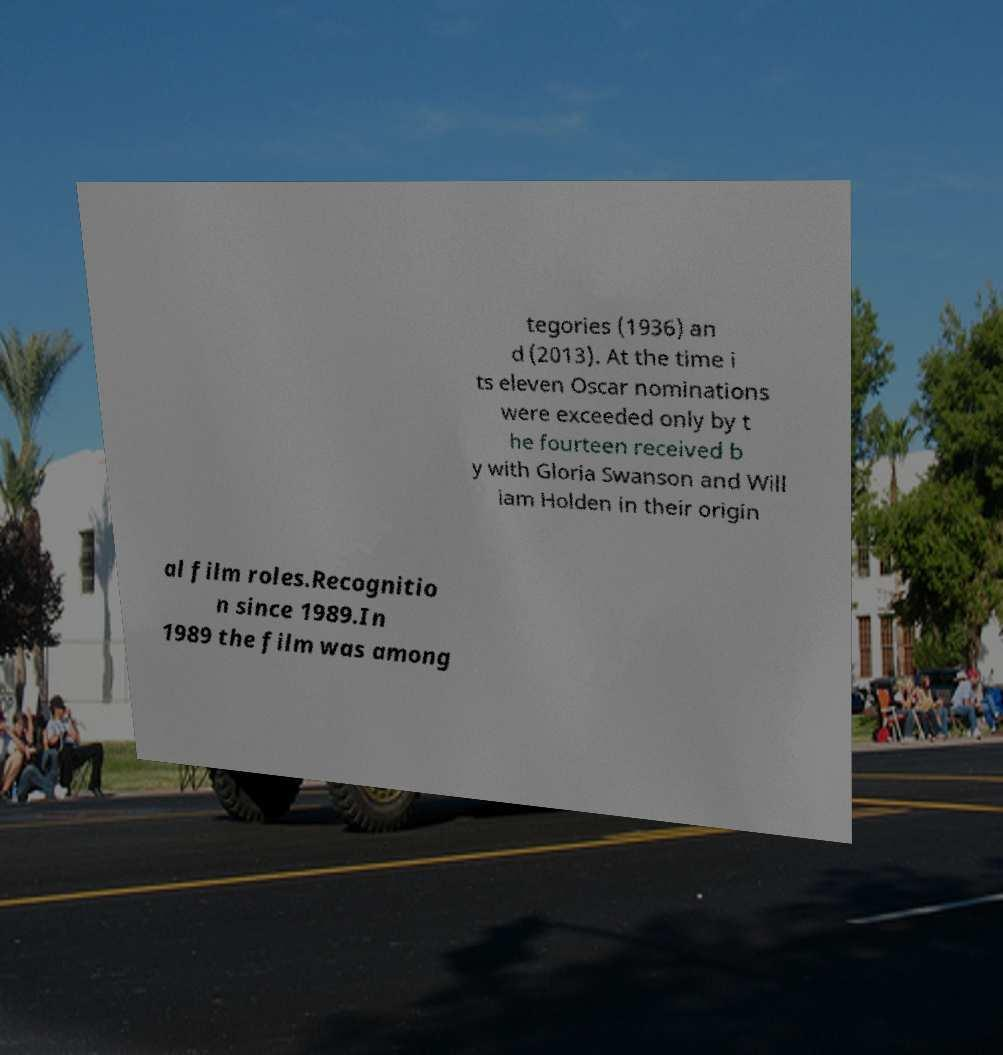Please identify and transcribe the text found in this image. tegories (1936) an d (2013). At the time i ts eleven Oscar nominations were exceeded only by t he fourteen received b y with Gloria Swanson and Will iam Holden in their origin al film roles.Recognitio n since 1989.In 1989 the film was among 